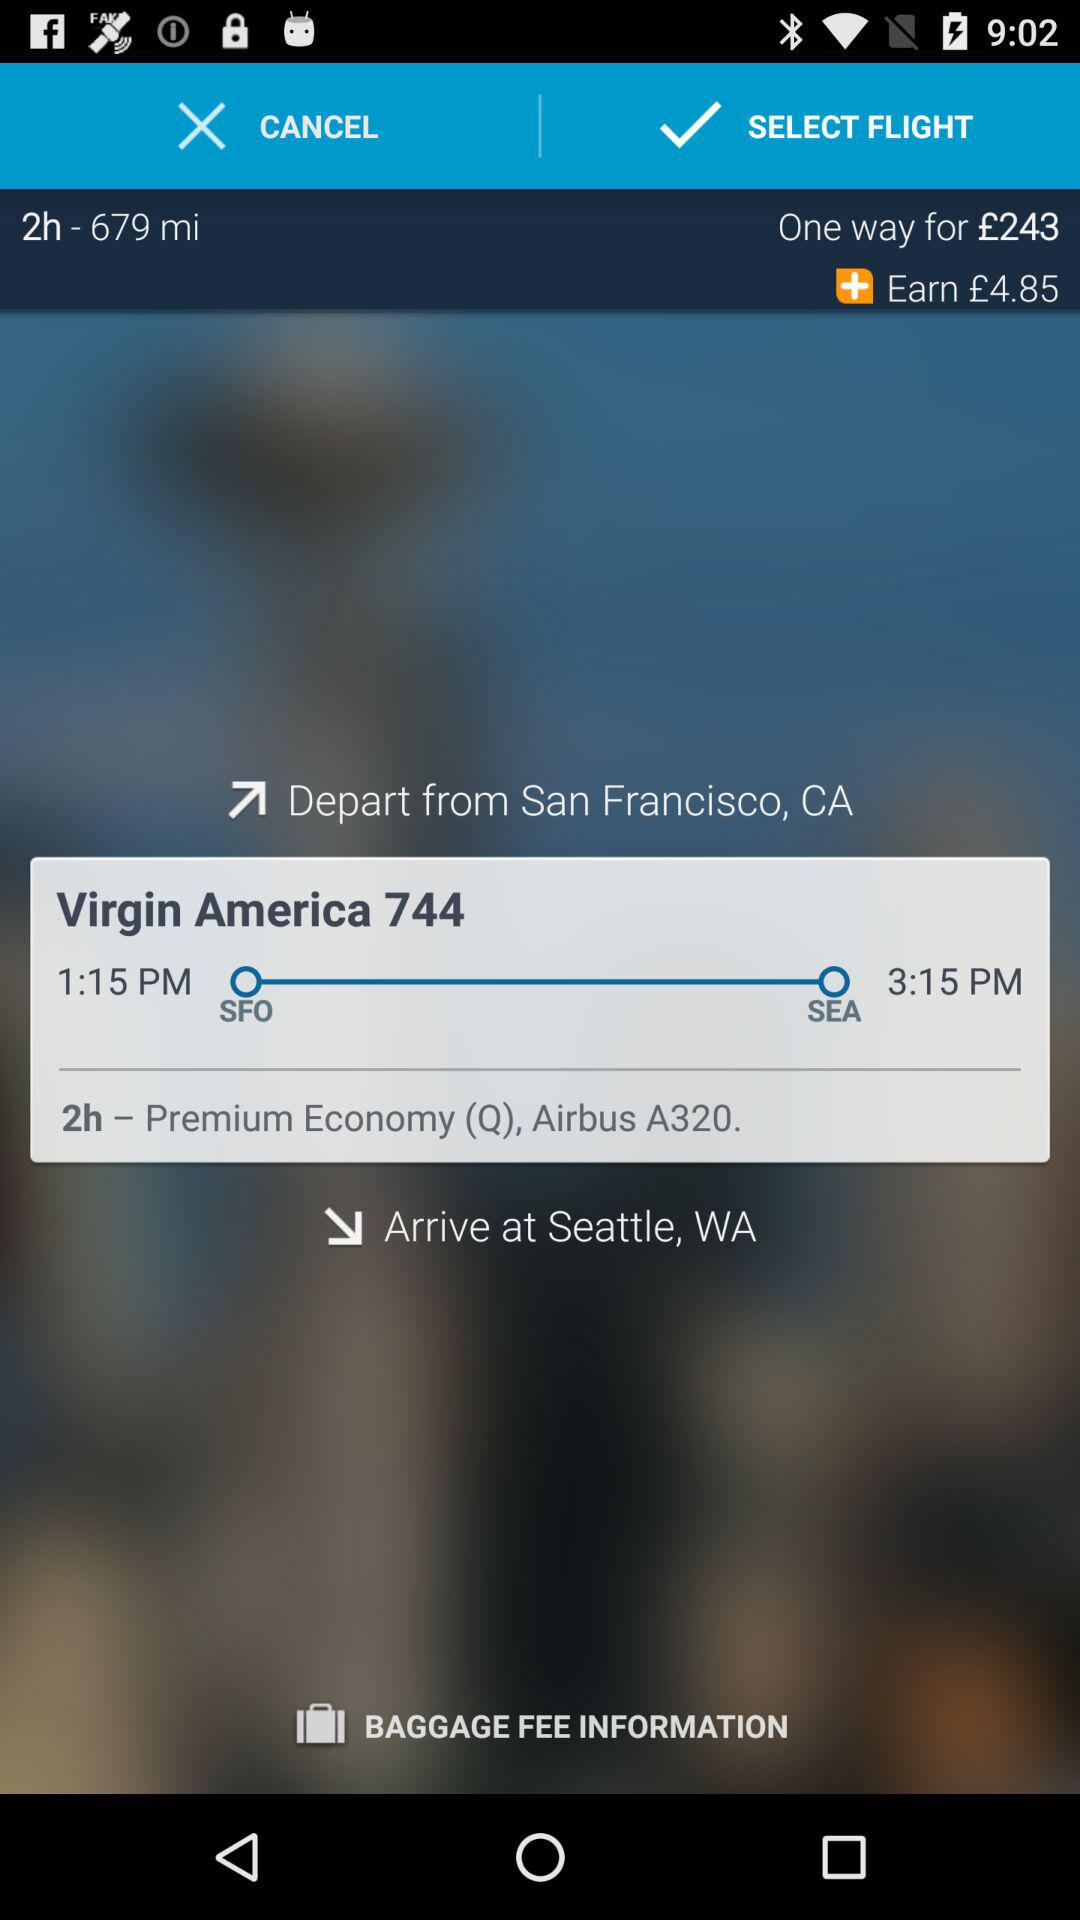What is the arrival time of the flight? The arrival time of the flight is 3:15 PM. 